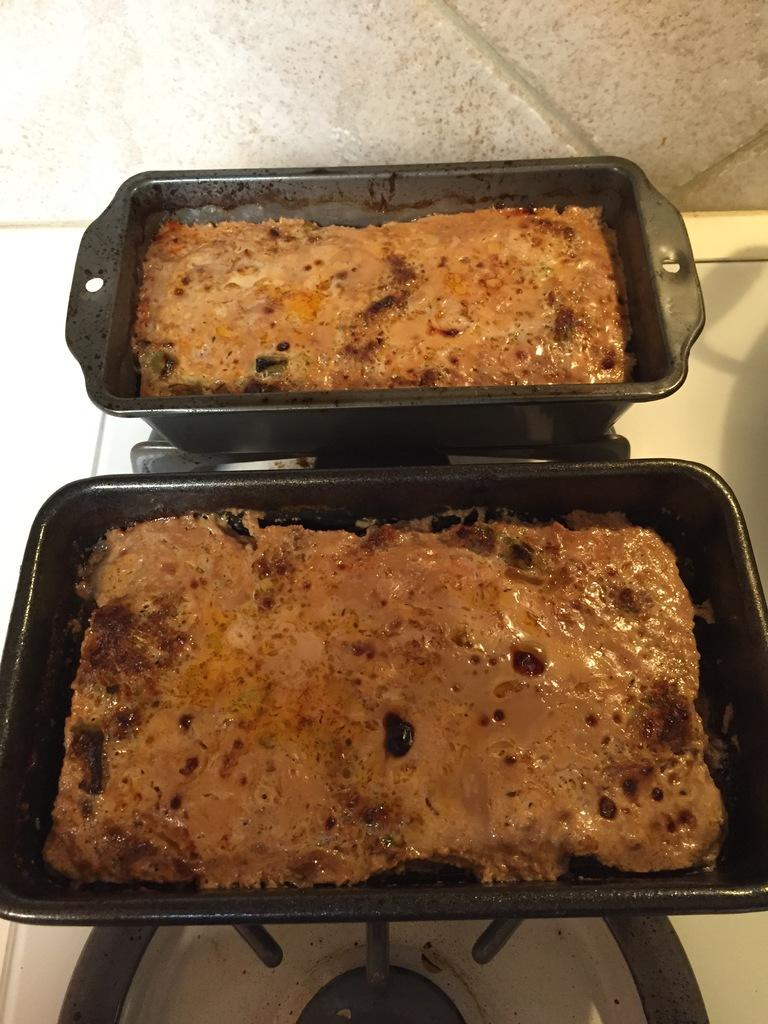What type of items are present in the image? There are food items in the image. How are the food items packaged or contained? The food items are in black color boxes. Where are the black color boxes located? The black color boxes are on a stove. What type of soup is being prepared on the door in the image? There is no soup or door present in the image; it features food items in black color boxes on a stove. 